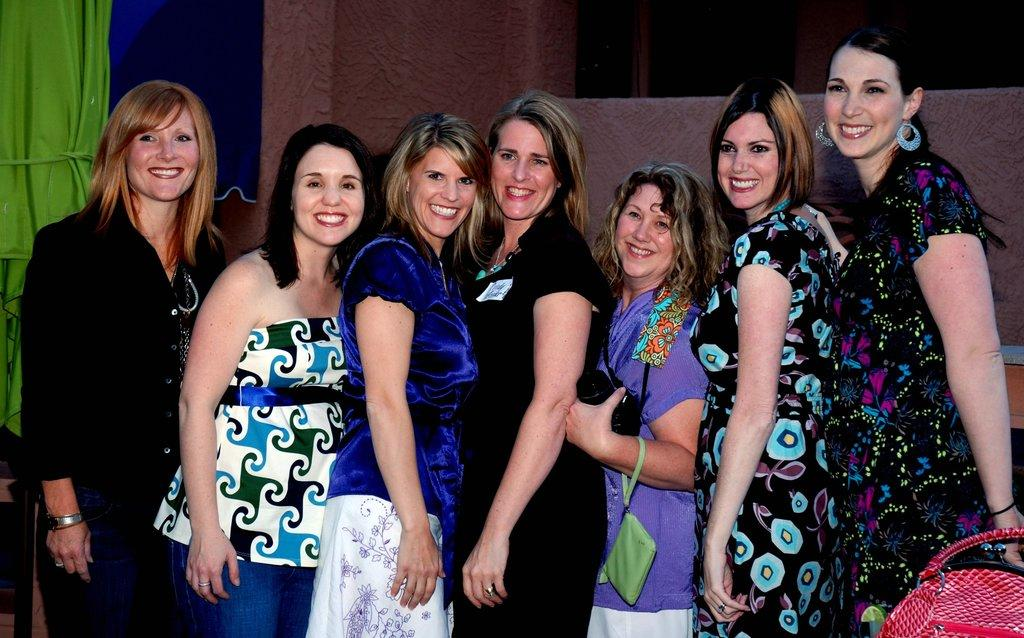What can be seen in the image? There is a group of girls in the image. Where is the handbag located in the image? The handbag is in the bottom right-hand side of the image. What is on the left side of the image? There is cloth on the left side of the image. What type of nose can be seen on the girls in the image? There is no specific nose mentioned or visible in the image; we can only see the girls' faces in general. 